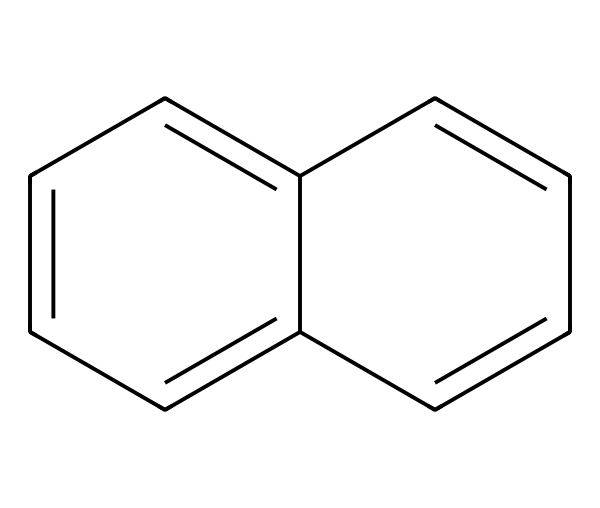What is the common name of this compound? The structure represented by the SMILES indicates an aromatic hydrocarbon with two fused benzene rings, which is commonly known as naphthalene.
Answer: naphthalene How many carbon atoms are present in naphthalene? Counting the carbon atoms in the structure, we see there are ten carbon atoms resulting from the two fused rings.
Answer: ten How many hydrogen atoms are attached to naphthalene? Each carbon in naphthalene is bonded in a way that there are eight hydrogen atoms surrounding the ten carbon atoms, after accounting for bonds between carbons.
Answer: eight Is naphthalene an aromatic compound? Naphthalene has a planar structure with a cyclic arrangement of carbon atoms containing delocalized pi electrons, confirming its classification as an aromatic compound.
Answer: yes What type of compound is naphthalene? Given that naphthalene consists entirely of carbon and hydrogen and exhibits high resonance stabilization, it qualifies as a hydrocarbon.
Answer: hydrocarbon Does naphthalene exhibit any polarity in its structure? Due to the symmetrical arrangement of the carbon atoms and the strong pi-bonding within the aromatic rings, naphthalene exhibits very low polarity.
Answer: low What is a common use for naphthalene? Naphthalene is well-known for its application in the production of mothballs, which are used to protect vintage textiles from insect damage.
Answer: mothballs 